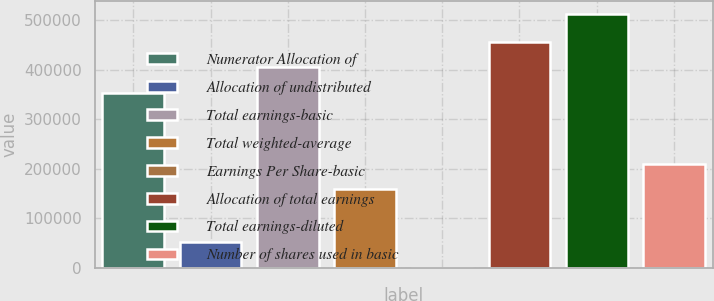Convert chart. <chart><loc_0><loc_0><loc_500><loc_500><bar_chart><fcel>Numerator Allocation of<fcel>Allocation of undistributed<fcel>Total earnings-basic<fcel>Total weighted-average<fcel>Earnings Per Share-basic<fcel>Allocation of total earnings<fcel>Total earnings-diluted<fcel>Number of shares used in basic<nl><fcel>352953<fcel>51297.3<fcel>404248<fcel>158471<fcel>2.4<fcel>455543<fcel>512951<fcel>209766<nl></chart> 